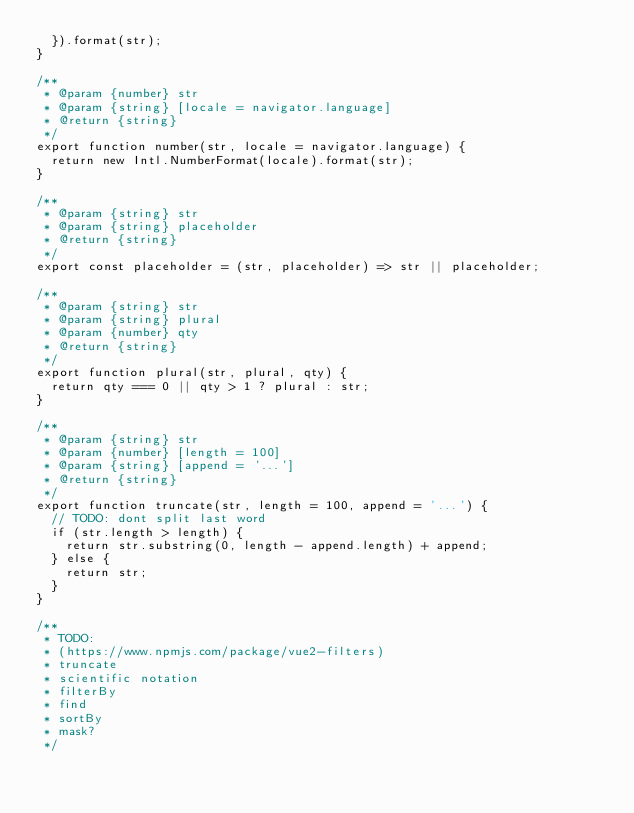Convert code to text. <code><loc_0><loc_0><loc_500><loc_500><_JavaScript_>  }).format(str);
}

/**
 * @param {number} str
 * @param {string} [locale = navigator.language]
 * @return {string}
 */
export function number(str, locale = navigator.language) {
  return new Intl.NumberFormat(locale).format(str);
}

/**
 * @param {string} str
 * @param {string} placeholder
 * @return {string}
 */
export const placeholder = (str, placeholder) => str || placeholder;

/**
 * @param {string} str
 * @param {string} plural
 * @param {number} qty
 * @return {string}
 */
export function plural(str, plural, qty) {
  return qty === 0 || qty > 1 ? plural : str;
}

/**
 * @param {string} str
 * @param {number} [length = 100]
 * @param {string} [append = '...']
 * @return {string}
 */
export function truncate(str, length = 100, append = '...') {
  // TODO: dont split last word
  if (str.length > length) {
    return str.substring(0, length - append.length) + append;
  } else {
    return str;
  }
}

/**
 * TODO:
 * (https://www.npmjs.com/package/vue2-filters)
 * truncate
 * scientific notation
 * filterBy
 * find
 * sortBy
 * mask?
 */
</code> 